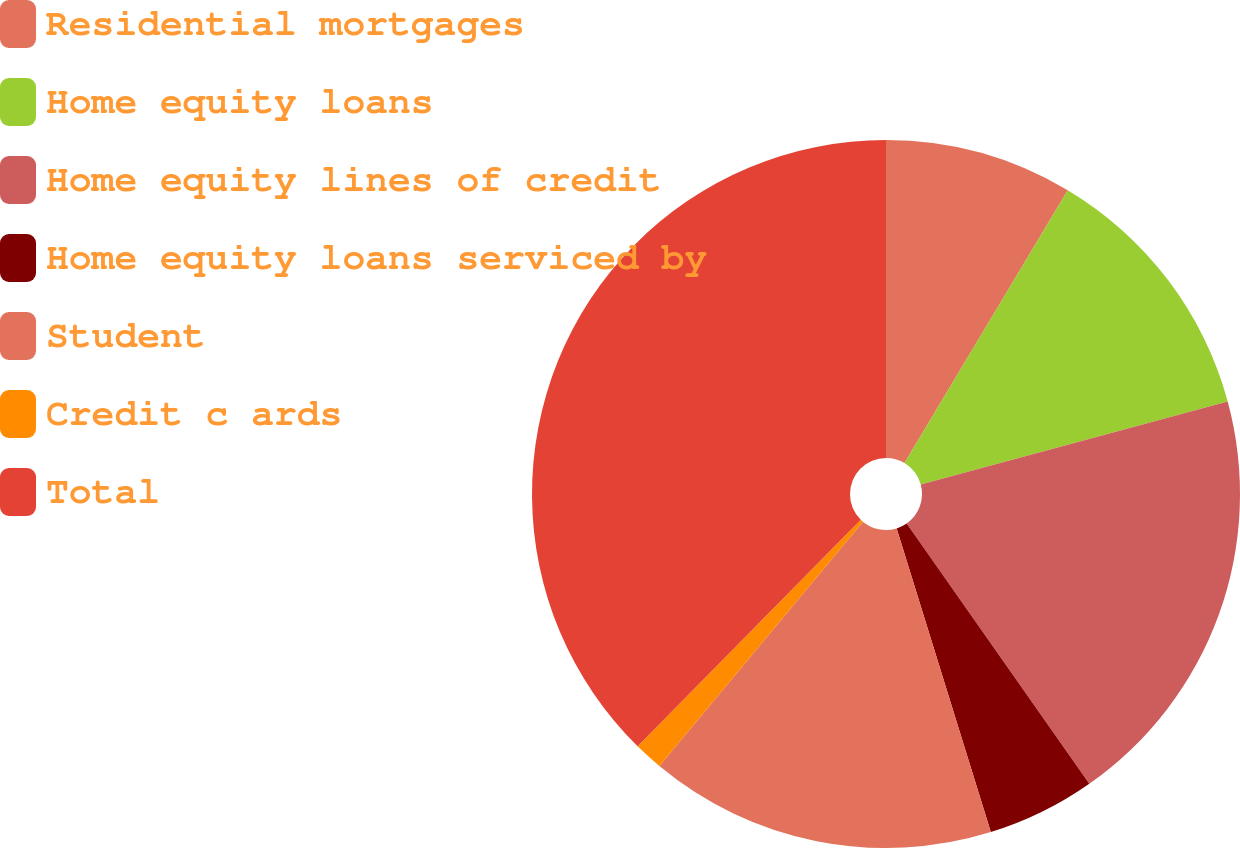<chart> <loc_0><loc_0><loc_500><loc_500><pie_chart><fcel>Residential mortgages<fcel>Home equity loans<fcel>Home equity lines of credit<fcel>Home equity loans serviced by<fcel>Student<fcel>Credit c ards<fcel>Total<nl><fcel>8.58%<fcel>12.21%<fcel>19.47%<fcel>4.95%<fcel>15.84%<fcel>1.32%<fcel>37.62%<nl></chart> 